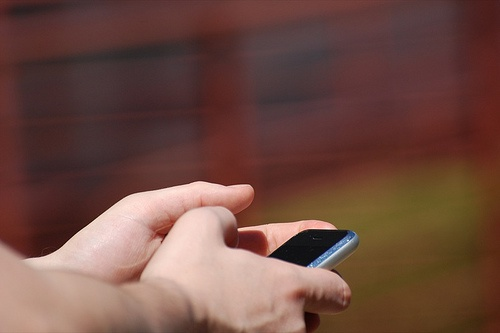Describe the objects in this image and their specific colors. I can see people in maroon, tan, pink, and brown tones and cell phone in maroon, black, and gray tones in this image. 